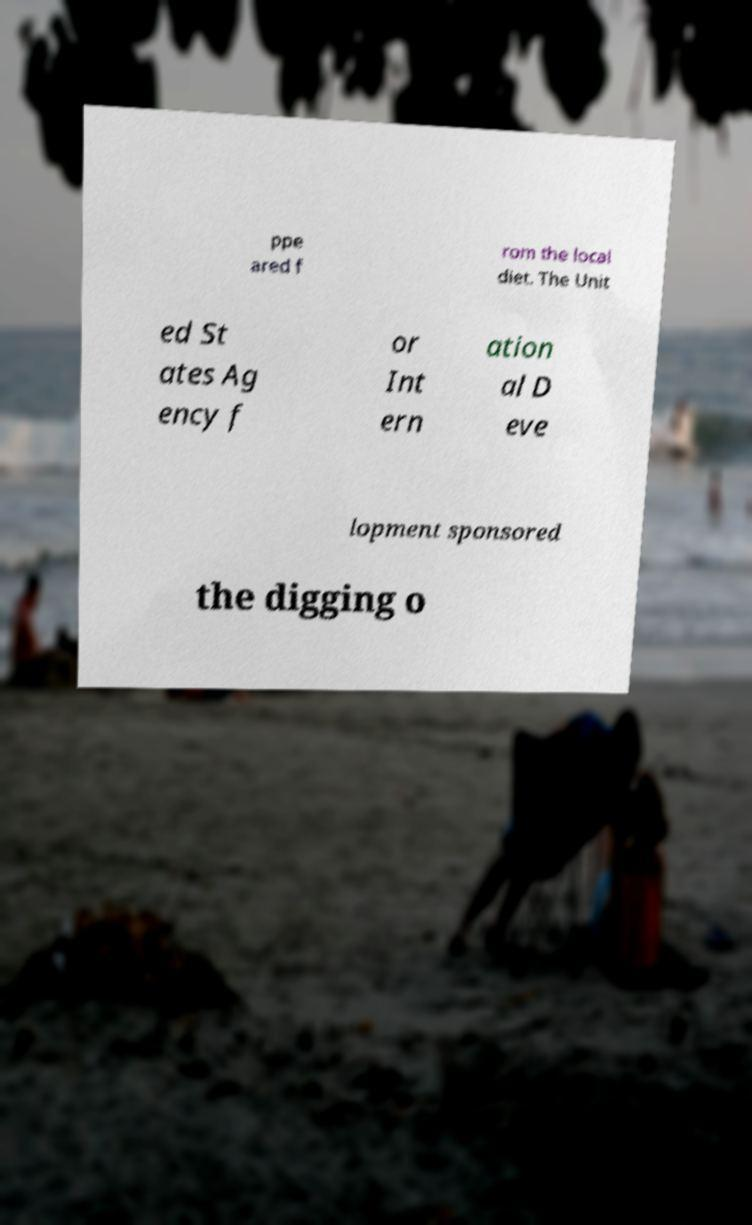What messages or text are displayed in this image? I need them in a readable, typed format. ppe ared f rom the local diet. The Unit ed St ates Ag ency f or Int ern ation al D eve lopment sponsored the digging o 